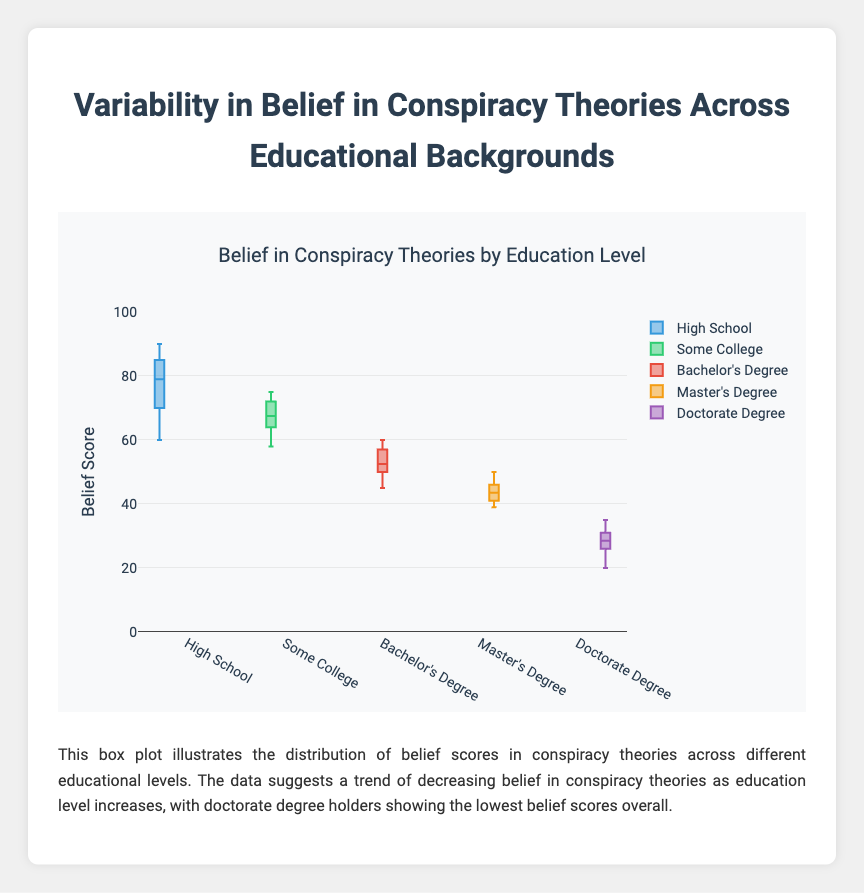What is the title of the plot? The title can be found at the top center of the figure.
Answer: Belief in Conspiracy Theories by Education Level What is the color of the box plot for those with a High School education level? The color of the box plot can be identified by looking at the legend or the box plot itself.
Answer: Blue Which education level has the highest median belief score in conspiracy theories? The median value of each group is given by the horizontal line inside the box for each education level. Compare these medians.
Answer: High School What is the interquartile range (IQR) for the Bachelor's Degree group? The IQR is the difference between the upper quartile (Q3) and the lower quartile (Q1) for the Bachelor's Degree box. Q3 and Q1 can be found by looking at the top and bottom edges of the box, respectively.
Answer: 10 Which education level shows the greatest variability in belief scores? Variability can be assessed by looking at the range or the spread of the box and whiskers for each education level. The group with the widest overall spread indicates the greatest variability.
Answer: High School Compare the medians of Master's Degree and Doctorate Degree groups. Which has a lower median? The median is indicated by the horizontal line inside the box. By comparing the median lines of both groups, we can see which is lower.
Answer: Doctorate Degree How does the spread of belief scores for "Some College" compare to "Bachelor's Degree"? Compare the range covered by the box and whiskers for both education levels. Pay attention to the height of the boxes and the length of the whiskers.
Answer: Some College has a larger spread What is the highest belief score observed for the Master's Degree group? The highest value is indicated by the upper whisker or any outliers beyond it, which for the Master's Degree group is the whisker tip.
Answer: 50 What does the box plot suggest about the relationship between education level and belief in conspiracy theories? Analyzing the general trend of medians and ranges across different education levels, this can be summarized.
Answer: Increasing education level tends to decrease belief in conspiracy theories How does the range of the High School group compare to the range of the Doctorate Degree group? The range is the difference between the maximum and minimum values, indicated by the whiskers for each group. Look for the farthest points of the whiskers for each group and compare the range.
Answer: High School has a larger range 